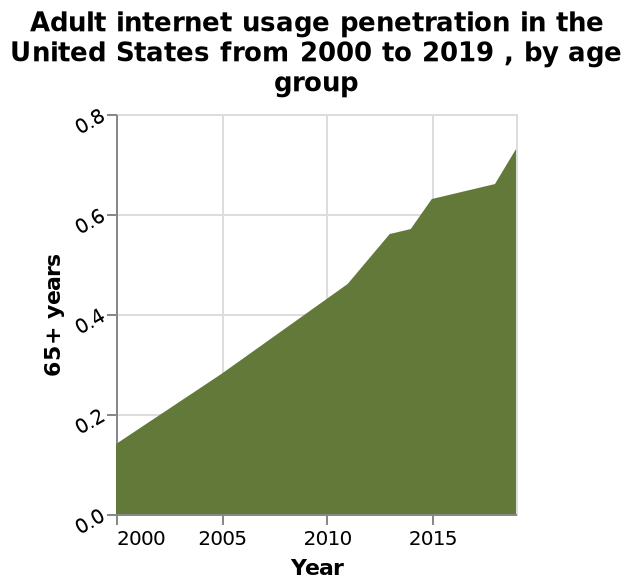<image>
please summary the statistics and relations of the chart Older generations are using the internet more now than in 2000. What is the time period covered by the area chart?  The area chart covers the time period from 2000 to 2019 in the United States. Are older generations using the internet less now than in 2000? No.Older generations are using the internet more now than in 2000. 